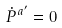Convert formula to latex. <formula><loc_0><loc_0><loc_500><loc_500>\dot { P } ^ { a ^ { \prime } } = 0</formula> 